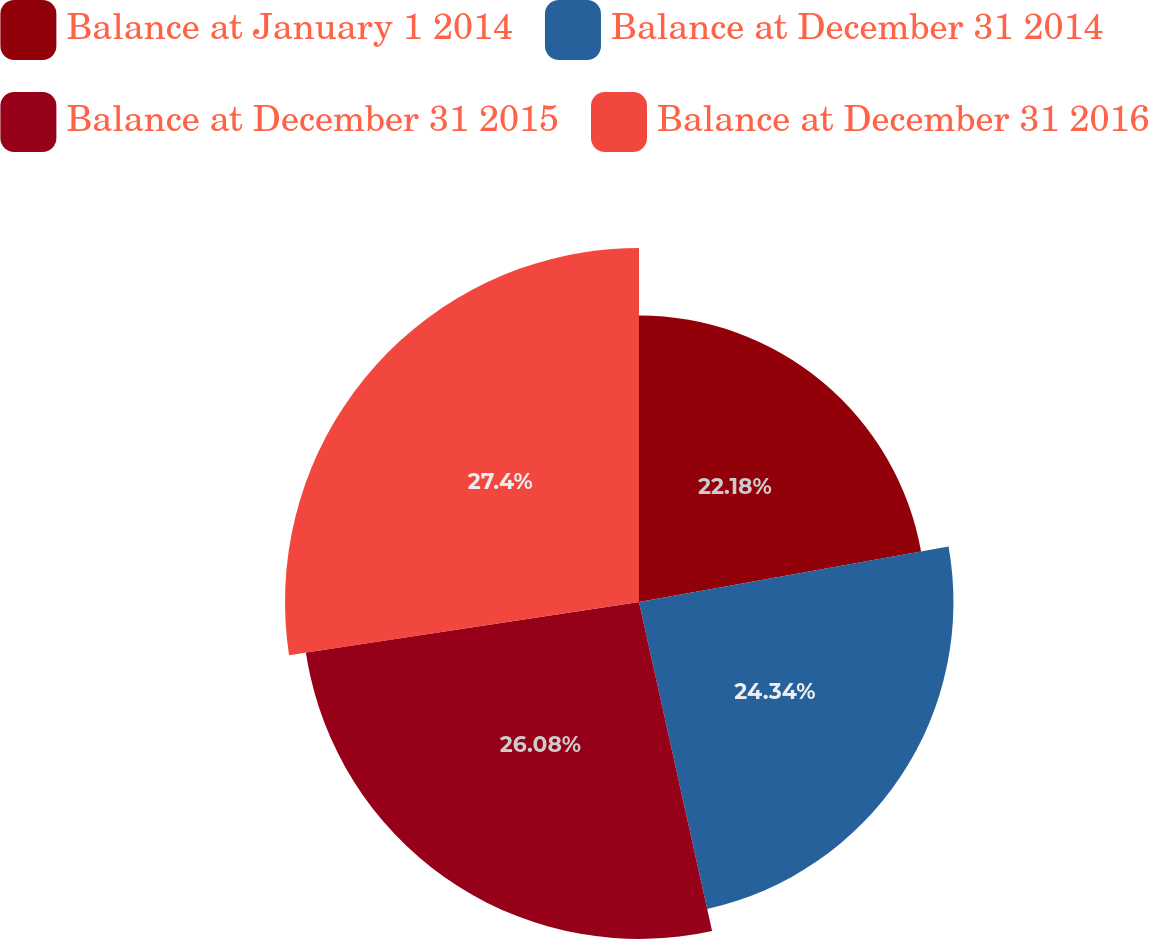Convert chart. <chart><loc_0><loc_0><loc_500><loc_500><pie_chart><fcel>Balance at January 1 2014<fcel>Balance at December 31 2014<fcel>Balance at December 31 2015<fcel>Balance at December 31 2016<nl><fcel>22.18%<fcel>24.34%<fcel>26.08%<fcel>27.4%<nl></chart> 